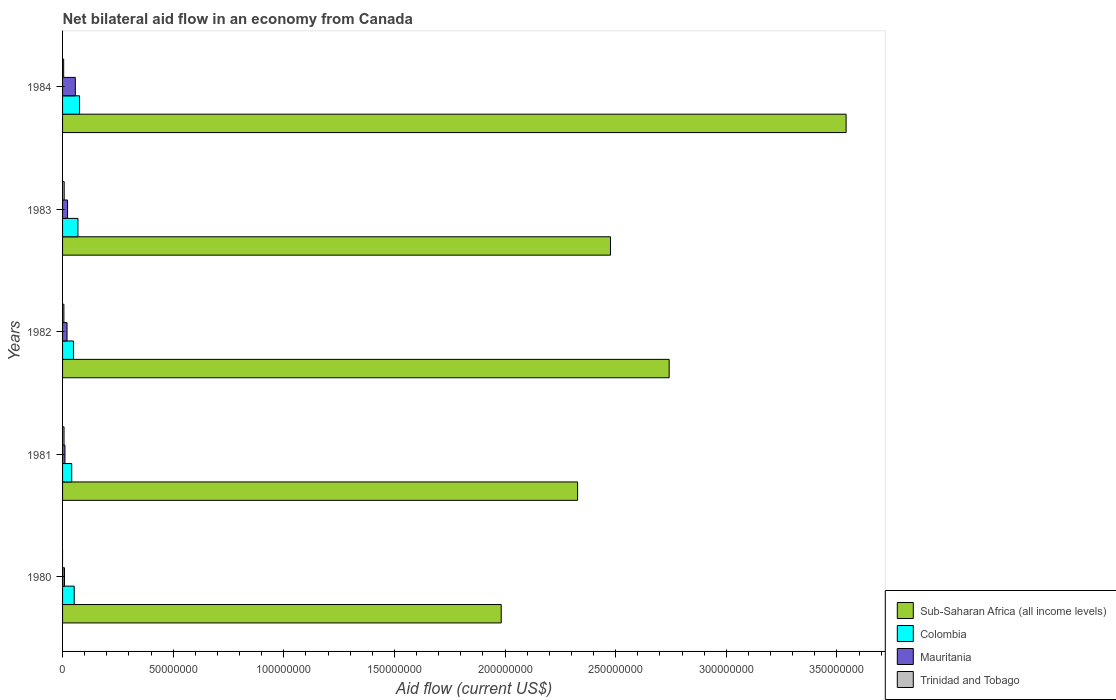How many bars are there on the 3rd tick from the bottom?
Provide a short and direct response. 4. In how many cases, is the number of bars for a given year not equal to the number of legend labels?
Your answer should be very brief. 1. What is the net bilateral aid flow in Colombia in 1984?
Your response must be concise. 7.67e+06. Across all years, what is the maximum net bilateral aid flow in Mauritania?
Give a very brief answer. 5.77e+06. Across all years, what is the minimum net bilateral aid flow in Colombia?
Your response must be concise. 4.14e+06. In which year was the net bilateral aid flow in Mauritania maximum?
Your answer should be very brief. 1984. What is the total net bilateral aid flow in Colombia in the graph?
Offer a very short reply. 2.90e+07. What is the difference between the net bilateral aid flow in Mauritania in 1980 and that in 1983?
Your answer should be compact. -1.38e+06. What is the difference between the net bilateral aid flow in Mauritania in 1982 and the net bilateral aid flow in Trinidad and Tobago in 1984?
Give a very brief answer. 1.52e+06. What is the average net bilateral aid flow in Colombia per year?
Give a very brief answer. 5.79e+06. In the year 1984, what is the difference between the net bilateral aid flow in Sub-Saharan Africa (all income levels) and net bilateral aid flow in Trinidad and Tobago?
Provide a short and direct response. 3.54e+08. What is the ratio of the net bilateral aid flow in Mauritania in 1980 to that in 1983?
Ensure brevity in your answer.  0.39. Is the net bilateral aid flow in Mauritania in 1981 less than that in 1984?
Keep it short and to the point. Yes. Is the difference between the net bilateral aid flow in Sub-Saharan Africa (all income levels) in 1981 and 1983 greater than the difference between the net bilateral aid flow in Trinidad and Tobago in 1981 and 1983?
Provide a short and direct response. No. What is the difference between the highest and the second highest net bilateral aid flow in Trinidad and Tobago?
Make the answer very short. 7.00e+04. What is the difference between the highest and the lowest net bilateral aid flow in Colombia?
Your answer should be very brief. 3.53e+06. In how many years, is the net bilateral aid flow in Mauritania greater than the average net bilateral aid flow in Mauritania taken over all years?
Give a very brief answer. 1. Is the sum of the net bilateral aid flow in Sub-Saharan Africa (all income levels) in 1980 and 1981 greater than the maximum net bilateral aid flow in Colombia across all years?
Provide a short and direct response. Yes. Is it the case that in every year, the sum of the net bilateral aid flow in Colombia and net bilateral aid flow in Mauritania is greater than the sum of net bilateral aid flow in Sub-Saharan Africa (all income levels) and net bilateral aid flow in Trinidad and Tobago?
Your response must be concise. Yes. How many bars are there?
Your answer should be very brief. 19. Does the graph contain any zero values?
Offer a very short reply. Yes. Where does the legend appear in the graph?
Your answer should be compact. Bottom right. How many legend labels are there?
Provide a short and direct response. 4. What is the title of the graph?
Give a very brief answer. Net bilateral aid flow in an economy from Canada. Does "New Caledonia" appear as one of the legend labels in the graph?
Your answer should be very brief. No. What is the label or title of the X-axis?
Your answer should be very brief. Aid flow (current US$). What is the Aid flow (current US$) of Sub-Saharan Africa (all income levels) in 1980?
Offer a very short reply. 1.98e+08. What is the Aid flow (current US$) in Colombia in 1980?
Keep it short and to the point. 5.27e+06. What is the Aid flow (current US$) of Mauritania in 1980?
Make the answer very short. 8.80e+05. What is the Aid flow (current US$) of Trinidad and Tobago in 1980?
Your response must be concise. 0. What is the Aid flow (current US$) of Sub-Saharan Africa (all income levels) in 1981?
Make the answer very short. 2.33e+08. What is the Aid flow (current US$) of Colombia in 1981?
Your answer should be compact. 4.14e+06. What is the Aid flow (current US$) in Mauritania in 1981?
Make the answer very short. 1.08e+06. What is the Aid flow (current US$) in Sub-Saharan Africa (all income levels) in 1982?
Ensure brevity in your answer.  2.74e+08. What is the Aid flow (current US$) of Colombia in 1982?
Your answer should be compact. 4.93e+06. What is the Aid flow (current US$) in Mauritania in 1982?
Give a very brief answer. 2.02e+06. What is the Aid flow (current US$) of Trinidad and Tobago in 1982?
Your response must be concise. 6.00e+05. What is the Aid flow (current US$) of Sub-Saharan Africa (all income levels) in 1983?
Make the answer very short. 2.48e+08. What is the Aid flow (current US$) in Colombia in 1983?
Ensure brevity in your answer.  6.95e+06. What is the Aid flow (current US$) of Mauritania in 1983?
Provide a short and direct response. 2.26e+06. What is the Aid flow (current US$) of Trinidad and Tobago in 1983?
Give a very brief answer. 7.30e+05. What is the Aid flow (current US$) of Sub-Saharan Africa (all income levels) in 1984?
Your answer should be compact. 3.54e+08. What is the Aid flow (current US$) of Colombia in 1984?
Offer a very short reply. 7.67e+06. What is the Aid flow (current US$) in Mauritania in 1984?
Your answer should be compact. 5.77e+06. Across all years, what is the maximum Aid flow (current US$) of Sub-Saharan Africa (all income levels)?
Keep it short and to the point. 3.54e+08. Across all years, what is the maximum Aid flow (current US$) of Colombia?
Offer a very short reply. 7.67e+06. Across all years, what is the maximum Aid flow (current US$) in Mauritania?
Ensure brevity in your answer.  5.77e+06. Across all years, what is the maximum Aid flow (current US$) of Trinidad and Tobago?
Ensure brevity in your answer.  7.30e+05. Across all years, what is the minimum Aid flow (current US$) of Sub-Saharan Africa (all income levels)?
Make the answer very short. 1.98e+08. Across all years, what is the minimum Aid flow (current US$) in Colombia?
Give a very brief answer. 4.14e+06. Across all years, what is the minimum Aid flow (current US$) in Mauritania?
Keep it short and to the point. 8.80e+05. Across all years, what is the minimum Aid flow (current US$) of Trinidad and Tobago?
Make the answer very short. 0. What is the total Aid flow (current US$) in Sub-Saharan Africa (all income levels) in the graph?
Offer a terse response. 1.31e+09. What is the total Aid flow (current US$) in Colombia in the graph?
Make the answer very short. 2.90e+07. What is the total Aid flow (current US$) of Mauritania in the graph?
Your answer should be compact. 1.20e+07. What is the total Aid flow (current US$) of Trinidad and Tobago in the graph?
Your answer should be very brief. 2.49e+06. What is the difference between the Aid flow (current US$) in Sub-Saharan Africa (all income levels) in 1980 and that in 1981?
Your response must be concise. -3.45e+07. What is the difference between the Aid flow (current US$) of Colombia in 1980 and that in 1981?
Offer a terse response. 1.13e+06. What is the difference between the Aid flow (current US$) of Sub-Saharan Africa (all income levels) in 1980 and that in 1982?
Give a very brief answer. -7.59e+07. What is the difference between the Aid flow (current US$) of Mauritania in 1980 and that in 1982?
Keep it short and to the point. -1.14e+06. What is the difference between the Aid flow (current US$) in Sub-Saharan Africa (all income levels) in 1980 and that in 1983?
Offer a very short reply. -4.94e+07. What is the difference between the Aid flow (current US$) of Colombia in 1980 and that in 1983?
Ensure brevity in your answer.  -1.68e+06. What is the difference between the Aid flow (current US$) of Mauritania in 1980 and that in 1983?
Provide a short and direct response. -1.38e+06. What is the difference between the Aid flow (current US$) of Sub-Saharan Africa (all income levels) in 1980 and that in 1984?
Offer a very short reply. -1.56e+08. What is the difference between the Aid flow (current US$) of Colombia in 1980 and that in 1984?
Offer a terse response. -2.40e+06. What is the difference between the Aid flow (current US$) of Mauritania in 1980 and that in 1984?
Ensure brevity in your answer.  -4.89e+06. What is the difference between the Aid flow (current US$) in Sub-Saharan Africa (all income levels) in 1981 and that in 1982?
Offer a very short reply. -4.14e+07. What is the difference between the Aid flow (current US$) in Colombia in 1981 and that in 1982?
Your answer should be very brief. -7.90e+05. What is the difference between the Aid flow (current US$) of Mauritania in 1981 and that in 1982?
Provide a short and direct response. -9.40e+05. What is the difference between the Aid flow (current US$) of Sub-Saharan Africa (all income levels) in 1981 and that in 1983?
Ensure brevity in your answer.  -1.49e+07. What is the difference between the Aid flow (current US$) of Colombia in 1981 and that in 1983?
Provide a short and direct response. -2.81e+06. What is the difference between the Aid flow (current US$) in Mauritania in 1981 and that in 1983?
Your response must be concise. -1.18e+06. What is the difference between the Aid flow (current US$) of Trinidad and Tobago in 1981 and that in 1983?
Your response must be concise. -7.00e+04. What is the difference between the Aid flow (current US$) of Sub-Saharan Africa (all income levels) in 1981 and that in 1984?
Give a very brief answer. -1.21e+08. What is the difference between the Aid flow (current US$) in Colombia in 1981 and that in 1984?
Offer a terse response. -3.53e+06. What is the difference between the Aid flow (current US$) of Mauritania in 1981 and that in 1984?
Offer a very short reply. -4.69e+06. What is the difference between the Aid flow (current US$) in Trinidad and Tobago in 1981 and that in 1984?
Your response must be concise. 1.60e+05. What is the difference between the Aid flow (current US$) of Sub-Saharan Africa (all income levels) in 1982 and that in 1983?
Offer a terse response. 2.65e+07. What is the difference between the Aid flow (current US$) of Colombia in 1982 and that in 1983?
Your response must be concise. -2.02e+06. What is the difference between the Aid flow (current US$) in Mauritania in 1982 and that in 1983?
Ensure brevity in your answer.  -2.40e+05. What is the difference between the Aid flow (current US$) of Trinidad and Tobago in 1982 and that in 1983?
Offer a terse response. -1.30e+05. What is the difference between the Aid flow (current US$) in Sub-Saharan Africa (all income levels) in 1982 and that in 1984?
Your answer should be compact. -8.00e+07. What is the difference between the Aid flow (current US$) in Colombia in 1982 and that in 1984?
Offer a very short reply. -2.74e+06. What is the difference between the Aid flow (current US$) of Mauritania in 1982 and that in 1984?
Make the answer very short. -3.75e+06. What is the difference between the Aid flow (current US$) of Trinidad and Tobago in 1982 and that in 1984?
Your answer should be compact. 1.00e+05. What is the difference between the Aid flow (current US$) in Sub-Saharan Africa (all income levels) in 1983 and that in 1984?
Provide a succinct answer. -1.06e+08. What is the difference between the Aid flow (current US$) in Colombia in 1983 and that in 1984?
Offer a very short reply. -7.20e+05. What is the difference between the Aid flow (current US$) of Mauritania in 1983 and that in 1984?
Your answer should be compact. -3.51e+06. What is the difference between the Aid flow (current US$) in Trinidad and Tobago in 1983 and that in 1984?
Keep it short and to the point. 2.30e+05. What is the difference between the Aid flow (current US$) in Sub-Saharan Africa (all income levels) in 1980 and the Aid flow (current US$) in Colombia in 1981?
Provide a succinct answer. 1.94e+08. What is the difference between the Aid flow (current US$) in Sub-Saharan Africa (all income levels) in 1980 and the Aid flow (current US$) in Mauritania in 1981?
Your answer should be compact. 1.97e+08. What is the difference between the Aid flow (current US$) of Sub-Saharan Africa (all income levels) in 1980 and the Aid flow (current US$) of Trinidad and Tobago in 1981?
Provide a short and direct response. 1.98e+08. What is the difference between the Aid flow (current US$) in Colombia in 1980 and the Aid flow (current US$) in Mauritania in 1981?
Give a very brief answer. 4.19e+06. What is the difference between the Aid flow (current US$) in Colombia in 1980 and the Aid flow (current US$) in Trinidad and Tobago in 1981?
Ensure brevity in your answer.  4.61e+06. What is the difference between the Aid flow (current US$) in Mauritania in 1980 and the Aid flow (current US$) in Trinidad and Tobago in 1981?
Your answer should be very brief. 2.20e+05. What is the difference between the Aid flow (current US$) of Sub-Saharan Africa (all income levels) in 1980 and the Aid flow (current US$) of Colombia in 1982?
Offer a very short reply. 1.93e+08. What is the difference between the Aid flow (current US$) in Sub-Saharan Africa (all income levels) in 1980 and the Aid flow (current US$) in Mauritania in 1982?
Give a very brief answer. 1.96e+08. What is the difference between the Aid flow (current US$) of Sub-Saharan Africa (all income levels) in 1980 and the Aid flow (current US$) of Trinidad and Tobago in 1982?
Give a very brief answer. 1.98e+08. What is the difference between the Aid flow (current US$) of Colombia in 1980 and the Aid flow (current US$) of Mauritania in 1982?
Ensure brevity in your answer.  3.25e+06. What is the difference between the Aid flow (current US$) of Colombia in 1980 and the Aid flow (current US$) of Trinidad and Tobago in 1982?
Offer a terse response. 4.67e+06. What is the difference between the Aid flow (current US$) of Sub-Saharan Africa (all income levels) in 1980 and the Aid flow (current US$) of Colombia in 1983?
Offer a terse response. 1.91e+08. What is the difference between the Aid flow (current US$) in Sub-Saharan Africa (all income levels) in 1980 and the Aid flow (current US$) in Mauritania in 1983?
Ensure brevity in your answer.  1.96e+08. What is the difference between the Aid flow (current US$) in Sub-Saharan Africa (all income levels) in 1980 and the Aid flow (current US$) in Trinidad and Tobago in 1983?
Ensure brevity in your answer.  1.98e+08. What is the difference between the Aid flow (current US$) of Colombia in 1980 and the Aid flow (current US$) of Mauritania in 1983?
Your answer should be very brief. 3.01e+06. What is the difference between the Aid flow (current US$) in Colombia in 1980 and the Aid flow (current US$) in Trinidad and Tobago in 1983?
Give a very brief answer. 4.54e+06. What is the difference between the Aid flow (current US$) of Mauritania in 1980 and the Aid flow (current US$) of Trinidad and Tobago in 1983?
Offer a very short reply. 1.50e+05. What is the difference between the Aid flow (current US$) in Sub-Saharan Africa (all income levels) in 1980 and the Aid flow (current US$) in Colombia in 1984?
Offer a very short reply. 1.91e+08. What is the difference between the Aid flow (current US$) in Sub-Saharan Africa (all income levels) in 1980 and the Aid flow (current US$) in Mauritania in 1984?
Keep it short and to the point. 1.92e+08. What is the difference between the Aid flow (current US$) in Sub-Saharan Africa (all income levels) in 1980 and the Aid flow (current US$) in Trinidad and Tobago in 1984?
Make the answer very short. 1.98e+08. What is the difference between the Aid flow (current US$) of Colombia in 1980 and the Aid flow (current US$) of Mauritania in 1984?
Make the answer very short. -5.00e+05. What is the difference between the Aid flow (current US$) of Colombia in 1980 and the Aid flow (current US$) of Trinidad and Tobago in 1984?
Provide a short and direct response. 4.77e+06. What is the difference between the Aid flow (current US$) in Sub-Saharan Africa (all income levels) in 1981 and the Aid flow (current US$) in Colombia in 1982?
Keep it short and to the point. 2.28e+08. What is the difference between the Aid flow (current US$) in Sub-Saharan Africa (all income levels) in 1981 and the Aid flow (current US$) in Mauritania in 1982?
Keep it short and to the point. 2.31e+08. What is the difference between the Aid flow (current US$) of Sub-Saharan Africa (all income levels) in 1981 and the Aid flow (current US$) of Trinidad and Tobago in 1982?
Ensure brevity in your answer.  2.32e+08. What is the difference between the Aid flow (current US$) of Colombia in 1981 and the Aid flow (current US$) of Mauritania in 1982?
Ensure brevity in your answer.  2.12e+06. What is the difference between the Aid flow (current US$) of Colombia in 1981 and the Aid flow (current US$) of Trinidad and Tobago in 1982?
Offer a terse response. 3.54e+06. What is the difference between the Aid flow (current US$) of Sub-Saharan Africa (all income levels) in 1981 and the Aid flow (current US$) of Colombia in 1983?
Your answer should be very brief. 2.26e+08. What is the difference between the Aid flow (current US$) in Sub-Saharan Africa (all income levels) in 1981 and the Aid flow (current US$) in Mauritania in 1983?
Provide a short and direct response. 2.31e+08. What is the difference between the Aid flow (current US$) of Sub-Saharan Africa (all income levels) in 1981 and the Aid flow (current US$) of Trinidad and Tobago in 1983?
Your answer should be very brief. 2.32e+08. What is the difference between the Aid flow (current US$) in Colombia in 1981 and the Aid flow (current US$) in Mauritania in 1983?
Offer a very short reply. 1.88e+06. What is the difference between the Aid flow (current US$) of Colombia in 1981 and the Aid flow (current US$) of Trinidad and Tobago in 1983?
Your response must be concise. 3.41e+06. What is the difference between the Aid flow (current US$) of Sub-Saharan Africa (all income levels) in 1981 and the Aid flow (current US$) of Colombia in 1984?
Make the answer very short. 2.25e+08. What is the difference between the Aid flow (current US$) in Sub-Saharan Africa (all income levels) in 1981 and the Aid flow (current US$) in Mauritania in 1984?
Your answer should be compact. 2.27e+08. What is the difference between the Aid flow (current US$) in Sub-Saharan Africa (all income levels) in 1981 and the Aid flow (current US$) in Trinidad and Tobago in 1984?
Give a very brief answer. 2.32e+08. What is the difference between the Aid flow (current US$) in Colombia in 1981 and the Aid flow (current US$) in Mauritania in 1984?
Give a very brief answer. -1.63e+06. What is the difference between the Aid flow (current US$) in Colombia in 1981 and the Aid flow (current US$) in Trinidad and Tobago in 1984?
Ensure brevity in your answer.  3.64e+06. What is the difference between the Aid flow (current US$) of Mauritania in 1981 and the Aid flow (current US$) of Trinidad and Tobago in 1984?
Keep it short and to the point. 5.80e+05. What is the difference between the Aid flow (current US$) in Sub-Saharan Africa (all income levels) in 1982 and the Aid flow (current US$) in Colombia in 1983?
Ensure brevity in your answer.  2.67e+08. What is the difference between the Aid flow (current US$) in Sub-Saharan Africa (all income levels) in 1982 and the Aid flow (current US$) in Mauritania in 1983?
Give a very brief answer. 2.72e+08. What is the difference between the Aid flow (current US$) in Sub-Saharan Africa (all income levels) in 1982 and the Aid flow (current US$) in Trinidad and Tobago in 1983?
Your response must be concise. 2.73e+08. What is the difference between the Aid flow (current US$) of Colombia in 1982 and the Aid flow (current US$) of Mauritania in 1983?
Your answer should be very brief. 2.67e+06. What is the difference between the Aid flow (current US$) in Colombia in 1982 and the Aid flow (current US$) in Trinidad and Tobago in 1983?
Provide a succinct answer. 4.20e+06. What is the difference between the Aid flow (current US$) in Mauritania in 1982 and the Aid flow (current US$) in Trinidad and Tobago in 1983?
Provide a short and direct response. 1.29e+06. What is the difference between the Aid flow (current US$) of Sub-Saharan Africa (all income levels) in 1982 and the Aid flow (current US$) of Colombia in 1984?
Your answer should be very brief. 2.66e+08. What is the difference between the Aid flow (current US$) in Sub-Saharan Africa (all income levels) in 1982 and the Aid flow (current US$) in Mauritania in 1984?
Provide a short and direct response. 2.68e+08. What is the difference between the Aid flow (current US$) in Sub-Saharan Africa (all income levels) in 1982 and the Aid flow (current US$) in Trinidad and Tobago in 1984?
Provide a short and direct response. 2.74e+08. What is the difference between the Aid flow (current US$) of Colombia in 1982 and the Aid flow (current US$) of Mauritania in 1984?
Give a very brief answer. -8.40e+05. What is the difference between the Aid flow (current US$) in Colombia in 1982 and the Aid flow (current US$) in Trinidad and Tobago in 1984?
Make the answer very short. 4.43e+06. What is the difference between the Aid flow (current US$) in Mauritania in 1982 and the Aid flow (current US$) in Trinidad and Tobago in 1984?
Offer a very short reply. 1.52e+06. What is the difference between the Aid flow (current US$) of Sub-Saharan Africa (all income levels) in 1983 and the Aid flow (current US$) of Colombia in 1984?
Your answer should be very brief. 2.40e+08. What is the difference between the Aid flow (current US$) of Sub-Saharan Africa (all income levels) in 1983 and the Aid flow (current US$) of Mauritania in 1984?
Give a very brief answer. 2.42e+08. What is the difference between the Aid flow (current US$) in Sub-Saharan Africa (all income levels) in 1983 and the Aid flow (current US$) in Trinidad and Tobago in 1984?
Provide a succinct answer. 2.47e+08. What is the difference between the Aid flow (current US$) in Colombia in 1983 and the Aid flow (current US$) in Mauritania in 1984?
Offer a terse response. 1.18e+06. What is the difference between the Aid flow (current US$) of Colombia in 1983 and the Aid flow (current US$) of Trinidad and Tobago in 1984?
Ensure brevity in your answer.  6.45e+06. What is the difference between the Aid flow (current US$) of Mauritania in 1983 and the Aid flow (current US$) of Trinidad and Tobago in 1984?
Your answer should be compact. 1.76e+06. What is the average Aid flow (current US$) in Sub-Saharan Africa (all income levels) per year?
Make the answer very short. 2.61e+08. What is the average Aid flow (current US$) in Colombia per year?
Make the answer very short. 5.79e+06. What is the average Aid flow (current US$) in Mauritania per year?
Keep it short and to the point. 2.40e+06. What is the average Aid flow (current US$) of Trinidad and Tobago per year?
Your response must be concise. 4.98e+05. In the year 1980, what is the difference between the Aid flow (current US$) of Sub-Saharan Africa (all income levels) and Aid flow (current US$) of Colombia?
Offer a terse response. 1.93e+08. In the year 1980, what is the difference between the Aid flow (current US$) of Sub-Saharan Africa (all income levels) and Aid flow (current US$) of Mauritania?
Your answer should be compact. 1.97e+08. In the year 1980, what is the difference between the Aid flow (current US$) in Colombia and Aid flow (current US$) in Mauritania?
Your answer should be very brief. 4.39e+06. In the year 1981, what is the difference between the Aid flow (current US$) in Sub-Saharan Africa (all income levels) and Aid flow (current US$) in Colombia?
Offer a terse response. 2.29e+08. In the year 1981, what is the difference between the Aid flow (current US$) of Sub-Saharan Africa (all income levels) and Aid flow (current US$) of Mauritania?
Make the answer very short. 2.32e+08. In the year 1981, what is the difference between the Aid flow (current US$) of Sub-Saharan Africa (all income levels) and Aid flow (current US$) of Trinidad and Tobago?
Ensure brevity in your answer.  2.32e+08. In the year 1981, what is the difference between the Aid flow (current US$) in Colombia and Aid flow (current US$) in Mauritania?
Keep it short and to the point. 3.06e+06. In the year 1981, what is the difference between the Aid flow (current US$) in Colombia and Aid flow (current US$) in Trinidad and Tobago?
Offer a very short reply. 3.48e+06. In the year 1981, what is the difference between the Aid flow (current US$) in Mauritania and Aid flow (current US$) in Trinidad and Tobago?
Keep it short and to the point. 4.20e+05. In the year 1982, what is the difference between the Aid flow (current US$) in Sub-Saharan Africa (all income levels) and Aid flow (current US$) in Colombia?
Your answer should be compact. 2.69e+08. In the year 1982, what is the difference between the Aid flow (current US$) of Sub-Saharan Africa (all income levels) and Aid flow (current US$) of Mauritania?
Provide a short and direct response. 2.72e+08. In the year 1982, what is the difference between the Aid flow (current US$) in Sub-Saharan Africa (all income levels) and Aid flow (current US$) in Trinidad and Tobago?
Ensure brevity in your answer.  2.74e+08. In the year 1982, what is the difference between the Aid flow (current US$) in Colombia and Aid flow (current US$) in Mauritania?
Give a very brief answer. 2.91e+06. In the year 1982, what is the difference between the Aid flow (current US$) in Colombia and Aid flow (current US$) in Trinidad and Tobago?
Give a very brief answer. 4.33e+06. In the year 1982, what is the difference between the Aid flow (current US$) of Mauritania and Aid flow (current US$) of Trinidad and Tobago?
Make the answer very short. 1.42e+06. In the year 1983, what is the difference between the Aid flow (current US$) in Sub-Saharan Africa (all income levels) and Aid flow (current US$) in Colombia?
Offer a terse response. 2.41e+08. In the year 1983, what is the difference between the Aid flow (current US$) in Sub-Saharan Africa (all income levels) and Aid flow (current US$) in Mauritania?
Offer a very short reply. 2.45e+08. In the year 1983, what is the difference between the Aid flow (current US$) in Sub-Saharan Africa (all income levels) and Aid flow (current US$) in Trinidad and Tobago?
Provide a short and direct response. 2.47e+08. In the year 1983, what is the difference between the Aid flow (current US$) of Colombia and Aid flow (current US$) of Mauritania?
Give a very brief answer. 4.69e+06. In the year 1983, what is the difference between the Aid flow (current US$) in Colombia and Aid flow (current US$) in Trinidad and Tobago?
Your response must be concise. 6.22e+06. In the year 1983, what is the difference between the Aid flow (current US$) of Mauritania and Aid flow (current US$) of Trinidad and Tobago?
Keep it short and to the point. 1.53e+06. In the year 1984, what is the difference between the Aid flow (current US$) of Sub-Saharan Africa (all income levels) and Aid flow (current US$) of Colombia?
Offer a very short reply. 3.46e+08. In the year 1984, what is the difference between the Aid flow (current US$) of Sub-Saharan Africa (all income levels) and Aid flow (current US$) of Mauritania?
Offer a very short reply. 3.48e+08. In the year 1984, what is the difference between the Aid flow (current US$) of Sub-Saharan Africa (all income levels) and Aid flow (current US$) of Trinidad and Tobago?
Ensure brevity in your answer.  3.54e+08. In the year 1984, what is the difference between the Aid flow (current US$) in Colombia and Aid flow (current US$) in Mauritania?
Make the answer very short. 1.90e+06. In the year 1984, what is the difference between the Aid flow (current US$) of Colombia and Aid flow (current US$) of Trinidad and Tobago?
Keep it short and to the point. 7.17e+06. In the year 1984, what is the difference between the Aid flow (current US$) in Mauritania and Aid flow (current US$) in Trinidad and Tobago?
Offer a terse response. 5.27e+06. What is the ratio of the Aid flow (current US$) of Sub-Saharan Africa (all income levels) in 1980 to that in 1981?
Give a very brief answer. 0.85. What is the ratio of the Aid flow (current US$) in Colombia in 1980 to that in 1981?
Make the answer very short. 1.27. What is the ratio of the Aid flow (current US$) in Mauritania in 1980 to that in 1981?
Offer a very short reply. 0.81. What is the ratio of the Aid flow (current US$) of Sub-Saharan Africa (all income levels) in 1980 to that in 1982?
Ensure brevity in your answer.  0.72. What is the ratio of the Aid flow (current US$) of Colombia in 1980 to that in 1982?
Give a very brief answer. 1.07. What is the ratio of the Aid flow (current US$) of Mauritania in 1980 to that in 1982?
Offer a terse response. 0.44. What is the ratio of the Aid flow (current US$) of Sub-Saharan Africa (all income levels) in 1980 to that in 1983?
Offer a terse response. 0.8. What is the ratio of the Aid flow (current US$) in Colombia in 1980 to that in 1983?
Offer a very short reply. 0.76. What is the ratio of the Aid flow (current US$) of Mauritania in 1980 to that in 1983?
Your answer should be very brief. 0.39. What is the ratio of the Aid flow (current US$) in Sub-Saharan Africa (all income levels) in 1980 to that in 1984?
Keep it short and to the point. 0.56. What is the ratio of the Aid flow (current US$) of Colombia in 1980 to that in 1984?
Offer a terse response. 0.69. What is the ratio of the Aid flow (current US$) of Mauritania in 1980 to that in 1984?
Give a very brief answer. 0.15. What is the ratio of the Aid flow (current US$) in Sub-Saharan Africa (all income levels) in 1981 to that in 1982?
Your answer should be compact. 0.85. What is the ratio of the Aid flow (current US$) of Colombia in 1981 to that in 1982?
Keep it short and to the point. 0.84. What is the ratio of the Aid flow (current US$) in Mauritania in 1981 to that in 1982?
Provide a short and direct response. 0.53. What is the ratio of the Aid flow (current US$) in Colombia in 1981 to that in 1983?
Your answer should be very brief. 0.6. What is the ratio of the Aid flow (current US$) of Mauritania in 1981 to that in 1983?
Offer a very short reply. 0.48. What is the ratio of the Aid flow (current US$) of Trinidad and Tobago in 1981 to that in 1983?
Make the answer very short. 0.9. What is the ratio of the Aid flow (current US$) of Sub-Saharan Africa (all income levels) in 1981 to that in 1984?
Your answer should be very brief. 0.66. What is the ratio of the Aid flow (current US$) in Colombia in 1981 to that in 1984?
Give a very brief answer. 0.54. What is the ratio of the Aid flow (current US$) in Mauritania in 1981 to that in 1984?
Offer a very short reply. 0.19. What is the ratio of the Aid flow (current US$) of Trinidad and Tobago in 1981 to that in 1984?
Give a very brief answer. 1.32. What is the ratio of the Aid flow (current US$) of Sub-Saharan Africa (all income levels) in 1982 to that in 1983?
Provide a succinct answer. 1.11. What is the ratio of the Aid flow (current US$) in Colombia in 1982 to that in 1983?
Provide a succinct answer. 0.71. What is the ratio of the Aid flow (current US$) of Mauritania in 1982 to that in 1983?
Make the answer very short. 0.89. What is the ratio of the Aid flow (current US$) in Trinidad and Tobago in 1982 to that in 1983?
Give a very brief answer. 0.82. What is the ratio of the Aid flow (current US$) in Sub-Saharan Africa (all income levels) in 1982 to that in 1984?
Your answer should be compact. 0.77. What is the ratio of the Aid flow (current US$) of Colombia in 1982 to that in 1984?
Keep it short and to the point. 0.64. What is the ratio of the Aid flow (current US$) in Mauritania in 1982 to that in 1984?
Keep it short and to the point. 0.35. What is the ratio of the Aid flow (current US$) in Sub-Saharan Africa (all income levels) in 1983 to that in 1984?
Your response must be concise. 0.7. What is the ratio of the Aid flow (current US$) in Colombia in 1983 to that in 1984?
Offer a terse response. 0.91. What is the ratio of the Aid flow (current US$) in Mauritania in 1983 to that in 1984?
Your response must be concise. 0.39. What is the ratio of the Aid flow (current US$) in Trinidad and Tobago in 1983 to that in 1984?
Ensure brevity in your answer.  1.46. What is the difference between the highest and the second highest Aid flow (current US$) of Sub-Saharan Africa (all income levels)?
Provide a short and direct response. 8.00e+07. What is the difference between the highest and the second highest Aid flow (current US$) of Colombia?
Your answer should be very brief. 7.20e+05. What is the difference between the highest and the second highest Aid flow (current US$) of Mauritania?
Your response must be concise. 3.51e+06. What is the difference between the highest and the second highest Aid flow (current US$) in Trinidad and Tobago?
Make the answer very short. 7.00e+04. What is the difference between the highest and the lowest Aid flow (current US$) of Sub-Saharan Africa (all income levels)?
Make the answer very short. 1.56e+08. What is the difference between the highest and the lowest Aid flow (current US$) of Colombia?
Your response must be concise. 3.53e+06. What is the difference between the highest and the lowest Aid flow (current US$) in Mauritania?
Provide a succinct answer. 4.89e+06. What is the difference between the highest and the lowest Aid flow (current US$) of Trinidad and Tobago?
Your answer should be very brief. 7.30e+05. 